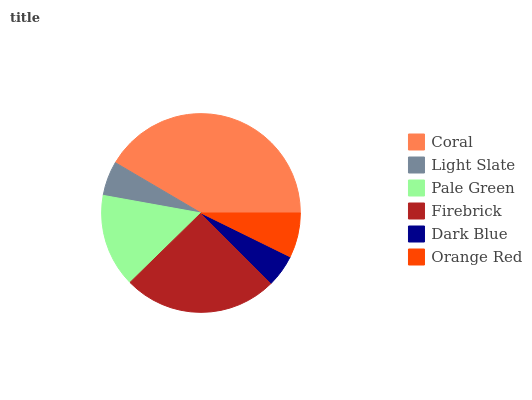Is Dark Blue the minimum?
Answer yes or no. Yes. Is Coral the maximum?
Answer yes or no. Yes. Is Light Slate the minimum?
Answer yes or no. No. Is Light Slate the maximum?
Answer yes or no. No. Is Coral greater than Light Slate?
Answer yes or no. Yes. Is Light Slate less than Coral?
Answer yes or no. Yes. Is Light Slate greater than Coral?
Answer yes or no. No. Is Coral less than Light Slate?
Answer yes or no. No. Is Pale Green the high median?
Answer yes or no. Yes. Is Orange Red the low median?
Answer yes or no. Yes. Is Dark Blue the high median?
Answer yes or no. No. Is Light Slate the low median?
Answer yes or no. No. 